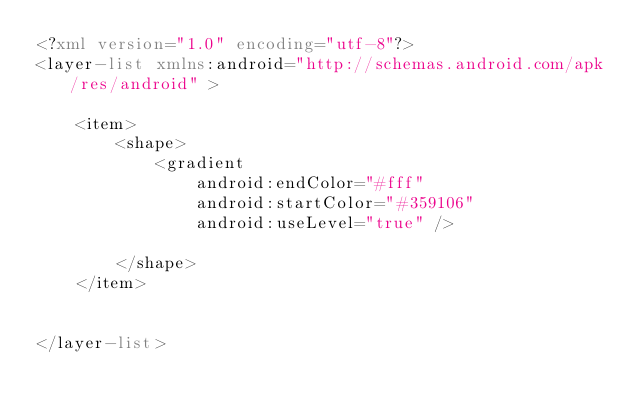<code> <loc_0><loc_0><loc_500><loc_500><_XML_><?xml version="1.0" encoding="utf-8"?>
<layer-list xmlns:android="http://schemas.android.com/apk/res/android" >

    <item>
        <shape>
            <gradient
                android:endColor="#fff"
                android:startColor="#359106"
                android:useLevel="true" />

        </shape>
    </item>


</layer-list>
</code> 